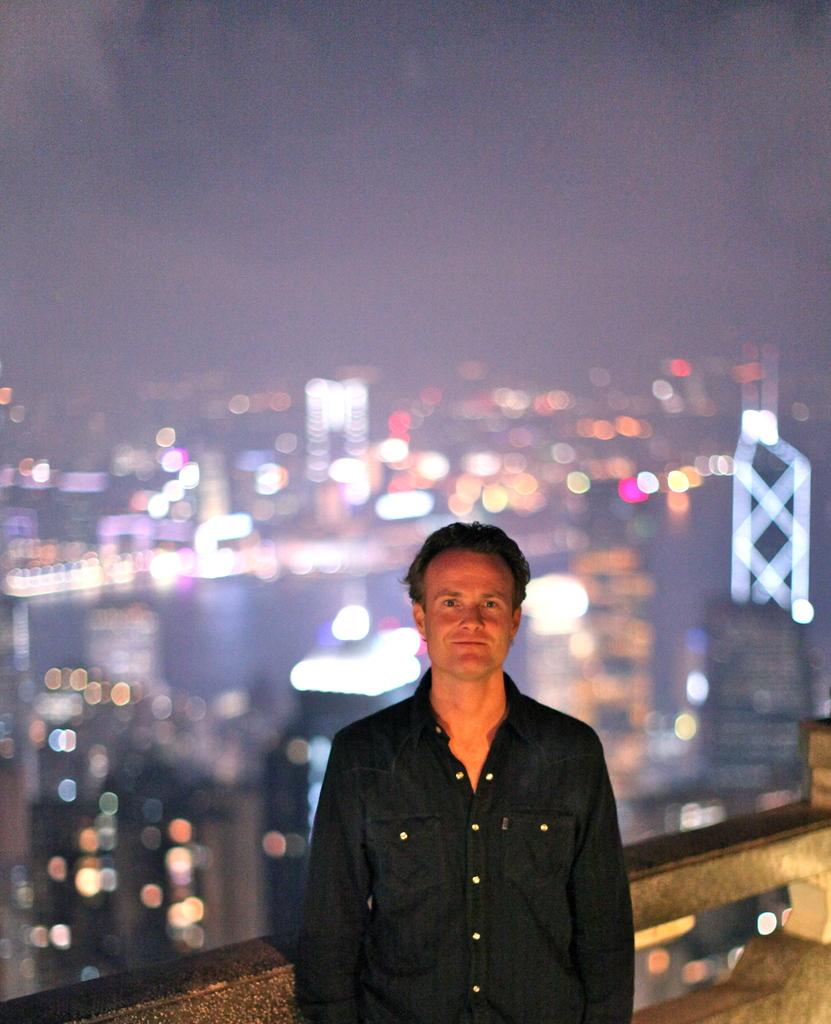What is the main subject of the image? There is a person in the image. What is the person doing in the image? The person is seeing (looking) and smiling. Where is the person located in the image? The person is standing near the railing. Can you describe the background of the image? The background of the image has a blurred view. What can be seen in the image besides the person? There are lights visible in the image, and the sky is visible as well. What type of silver bead is the person wearing on their lip in the image? There is no silver bead or any jewelry visible on the person's lip in the image. 